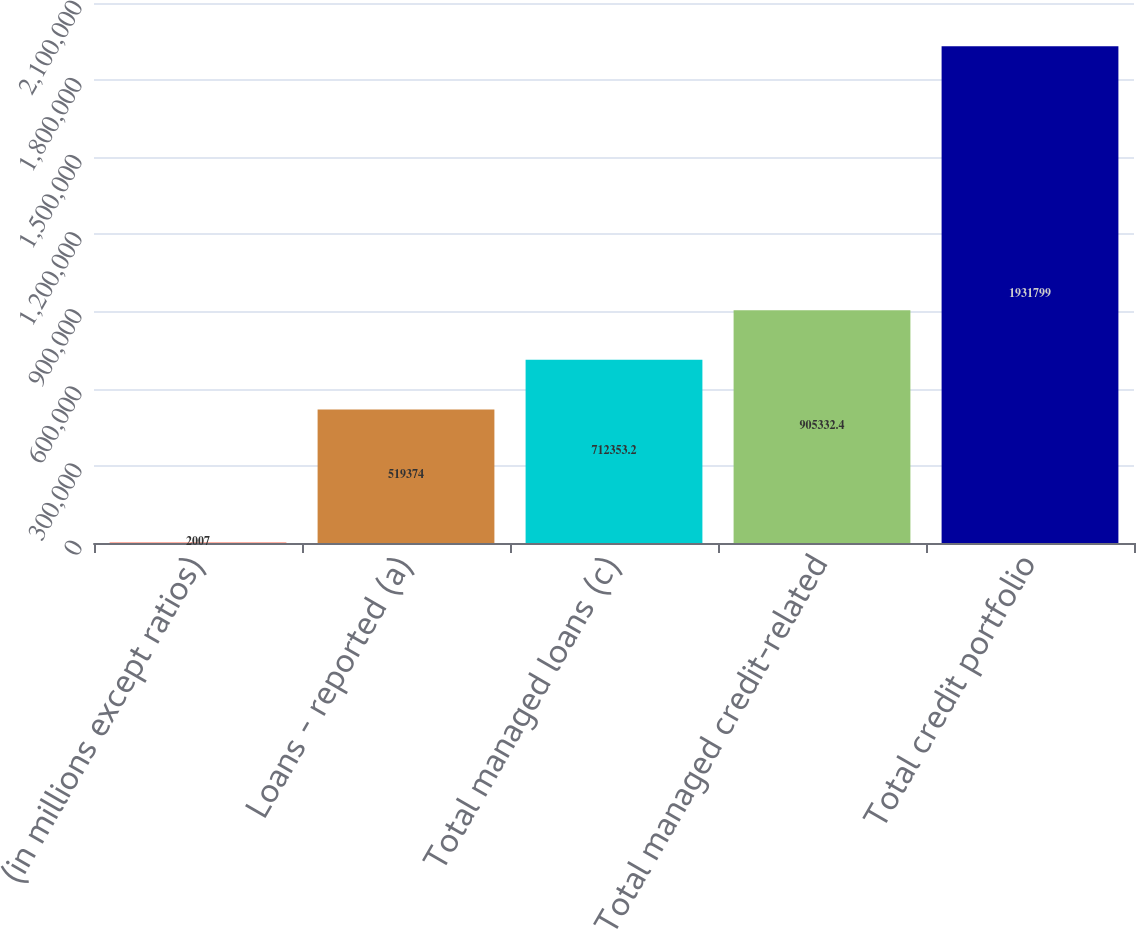Convert chart to OTSL. <chart><loc_0><loc_0><loc_500><loc_500><bar_chart><fcel>(in millions except ratios)<fcel>Loans - reported (a)<fcel>Total managed loans (c)<fcel>Total managed credit-related<fcel>Total credit portfolio<nl><fcel>2007<fcel>519374<fcel>712353<fcel>905332<fcel>1.9318e+06<nl></chart> 